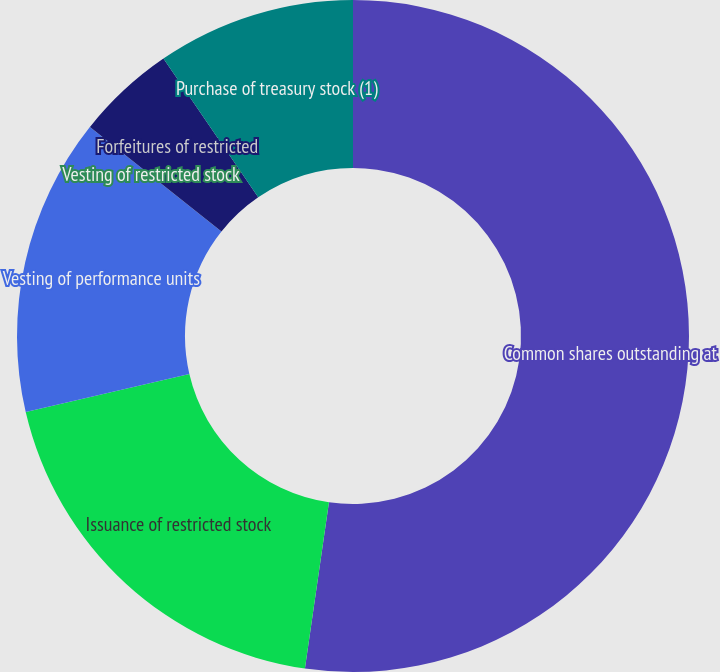Convert chart to OTSL. <chart><loc_0><loc_0><loc_500><loc_500><pie_chart><fcel>Common shares outstanding at<fcel>Issuance of restricted stock<fcel>Vesting of performance units<fcel>Vesting of restricted stock<fcel>Forfeitures of restricted<fcel>Purchase of treasury stock (1)<nl><fcel>52.28%<fcel>19.08%<fcel>14.31%<fcel>0.01%<fcel>4.77%<fcel>9.54%<nl></chart> 